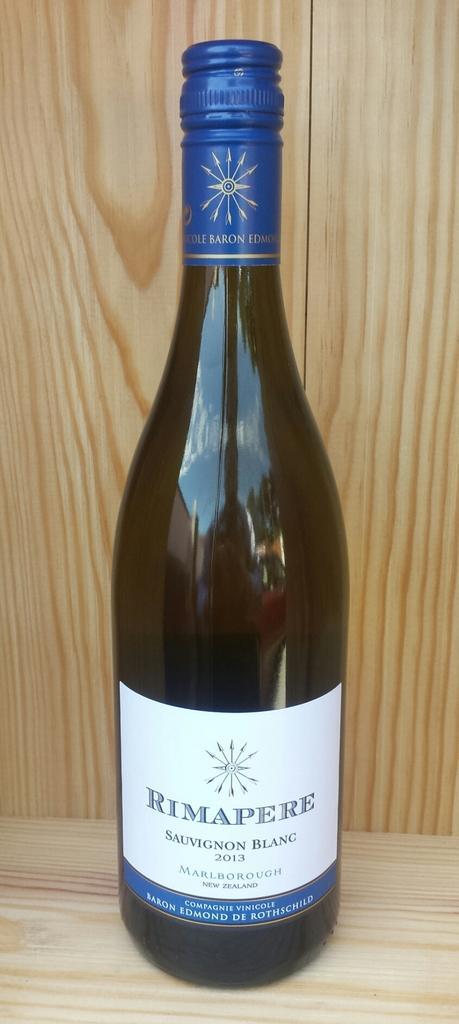Please provide a concise description of this image. In this image there is a bottle on a table, in the background there is a wooden wall. 